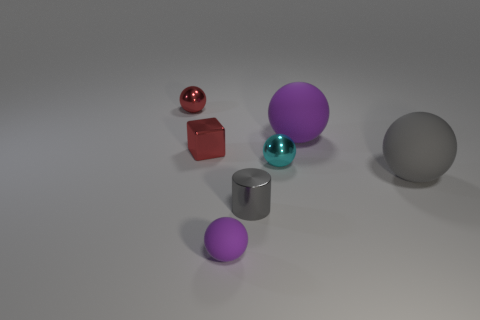Subtract all gray blocks. Subtract all blue cylinders. How many blocks are left? 1 Add 1 blue metallic cylinders. How many objects exist? 8 Subtract all cylinders. How many objects are left? 6 Add 6 gray rubber spheres. How many gray rubber spheres are left? 7 Add 3 big yellow metal balls. How many big yellow metal balls exist? 3 Subtract 0 green balls. How many objects are left? 7 Subtract all tiny cyan spheres. Subtract all red metallic things. How many objects are left? 4 